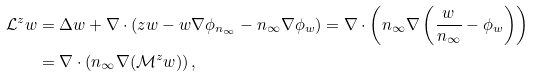<formula> <loc_0><loc_0><loc_500><loc_500>\mathcal { L } ^ { z } w & = \Delta w + \nabla \cdot ( z w - w \nabla \phi _ { n _ { \infty } } - n _ { \infty } \nabla \phi _ { w } ) = \nabla \cdot \left ( n _ { \infty } \nabla \left ( \frac { w } { n _ { \infty } } - \phi _ { w } \right ) \right ) \\ & = \nabla \cdot \left ( n _ { \infty } \nabla ( \mathcal { M } ^ { z } w ) \right ) ,</formula> 